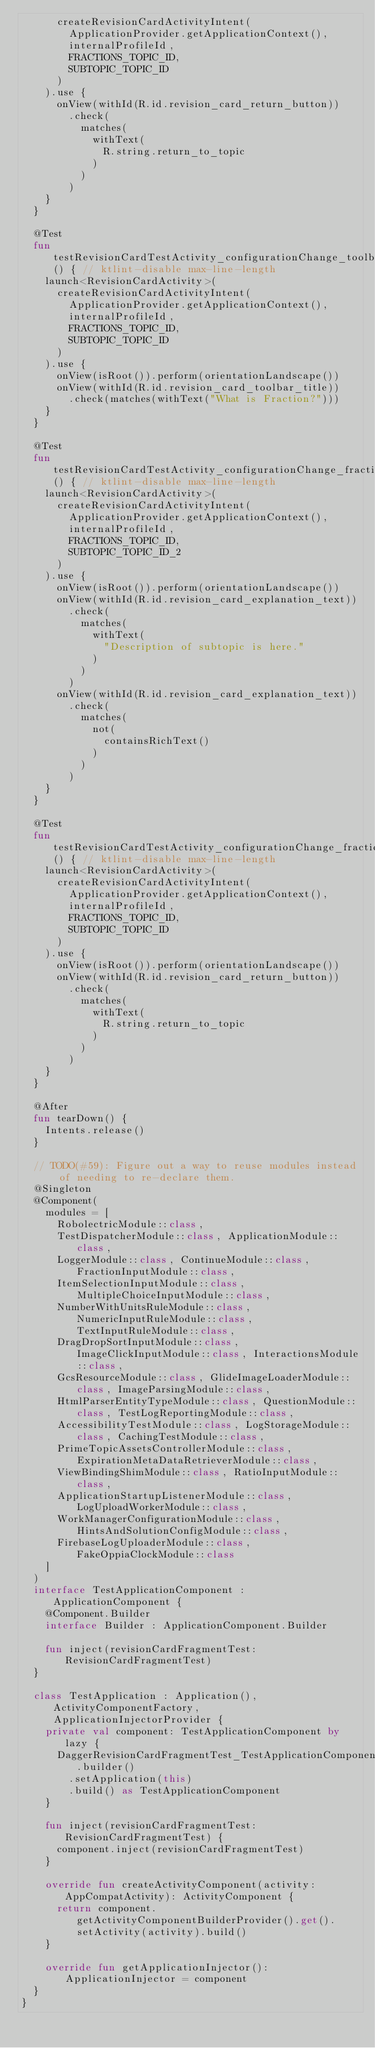Convert code to text. <code><loc_0><loc_0><loc_500><loc_500><_Kotlin_>      createRevisionCardActivityIntent(
        ApplicationProvider.getApplicationContext(),
        internalProfileId,
        FRACTIONS_TOPIC_ID,
        SUBTOPIC_TOPIC_ID
      )
    ).use {
      onView(withId(R.id.revision_card_return_button))
        .check(
          matches(
            withText(
              R.string.return_to_topic
            )
          )
        )
    }
  }

  @Test
  fun testRevisionCardTestActivity_configurationChange_toolbarTitle_fractionSubtopicId1_isDisplayedCorrectly() { // ktlint-disable max-line-length
    launch<RevisionCardActivity>(
      createRevisionCardActivityIntent(
        ApplicationProvider.getApplicationContext(),
        internalProfileId,
        FRACTIONS_TOPIC_ID,
        SUBTOPIC_TOPIC_ID
      )
    ).use {
      onView(isRoot()).perform(orientationLandscape())
      onView(withId(R.id.revision_card_toolbar_title))
        .check(matches(withText("What is Fraction?")))
    }
  }

  @Test
  fun testRevisionCardTestActivity_configurationChange_fractionSubtopicId2_checkExplanationAreDisplayedSuccessfully() { // ktlint-disable max-line-length
    launch<RevisionCardActivity>(
      createRevisionCardActivityIntent(
        ApplicationProvider.getApplicationContext(),
        internalProfileId,
        FRACTIONS_TOPIC_ID,
        SUBTOPIC_TOPIC_ID_2
      )
    ).use {
      onView(isRoot()).perform(orientationLandscape())
      onView(withId(R.id.revision_card_explanation_text))
        .check(
          matches(
            withText(
              "Description of subtopic is here."
            )
          )
        )
      onView(withId(R.id.revision_card_explanation_text))
        .check(
          matches(
            not(
              containsRichText()
            )
          )
        )
    }
  }

  @Test
  fun testRevisionCardTestActivity_configurationChange_fractionSubtopicId1_checkReturnToTopicButtonIsDisplayedSuccessfully() { // ktlint-disable max-line-length
    launch<RevisionCardActivity>(
      createRevisionCardActivityIntent(
        ApplicationProvider.getApplicationContext(),
        internalProfileId,
        FRACTIONS_TOPIC_ID,
        SUBTOPIC_TOPIC_ID
      )
    ).use {
      onView(isRoot()).perform(orientationLandscape())
      onView(withId(R.id.revision_card_return_button))
        .check(
          matches(
            withText(
              R.string.return_to_topic
            )
          )
        )
    }
  }

  @After
  fun tearDown() {
    Intents.release()
  }

  // TODO(#59): Figure out a way to reuse modules instead of needing to re-declare them.
  @Singleton
  @Component(
    modules = [
      RobolectricModule::class,
      TestDispatcherModule::class, ApplicationModule::class,
      LoggerModule::class, ContinueModule::class, FractionInputModule::class,
      ItemSelectionInputModule::class, MultipleChoiceInputModule::class,
      NumberWithUnitsRuleModule::class, NumericInputRuleModule::class, TextInputRuleModule::class,
      DragDropSortInputModule::class, ImageClickInputModule::class, InteractionsModule::class,
      GcsResourceModule::class, GlideImageLoaderModule::class, ImageParsingModule::class,
      HtmlParserEntityTypeModule::class, QuestionModule::class, TestLogReportingModule::class,
      AccessibilityTestModule::class, LogStorageModule::class, CachingTestModule::class,
      PrimeTopicAssetsControllerModule::class, ExpirationMetaDataRetrieverModule::class,
      ViewBindingShimModule::class, RatioInputModule::class,
      ApplicationStartupListenerModule::class, LogUploadWorkerModule::class,
      WorkManagerConfigurationModule::class, HintsAndSolutionConfigModule::class,
      FirebaseLogUploaderModule::class, FakeOppiaClockModule::class
    ]
  )
  interface TestApplicationComponent : ApplicationComponent {
    @Component.Builder
    interface Builder : ApplicationComponent.Builder

    fun inject(revisionCardFragmentTest: RevisionCardFragmentTest)
  }

  class TestApplication : Application(), ActivityComponentFactory, ApplicationInjectorProvider {
    private val component: TestApplicationComponent by lazy {
      DaggerRevisionCardFragmentTest_TestApplicationComponent.builder()
        .setApplication(this)
        .build() as TestApplicationComponent
    }

    fun inject(revisionCardFragmentTest: RevisionCardFragmentTest) {
      component.inject(revisionCardFragmentTest)
    }

    override fun createActivityComponent(activity: AppCompatActivity): ActivityComponent {
      return component.getActivityComponentBuilderProvider().get().setActivity(activity).build()
    }

    override fun getApplicationInjector(): ApplicationInjector = component
  }
}
</code> 